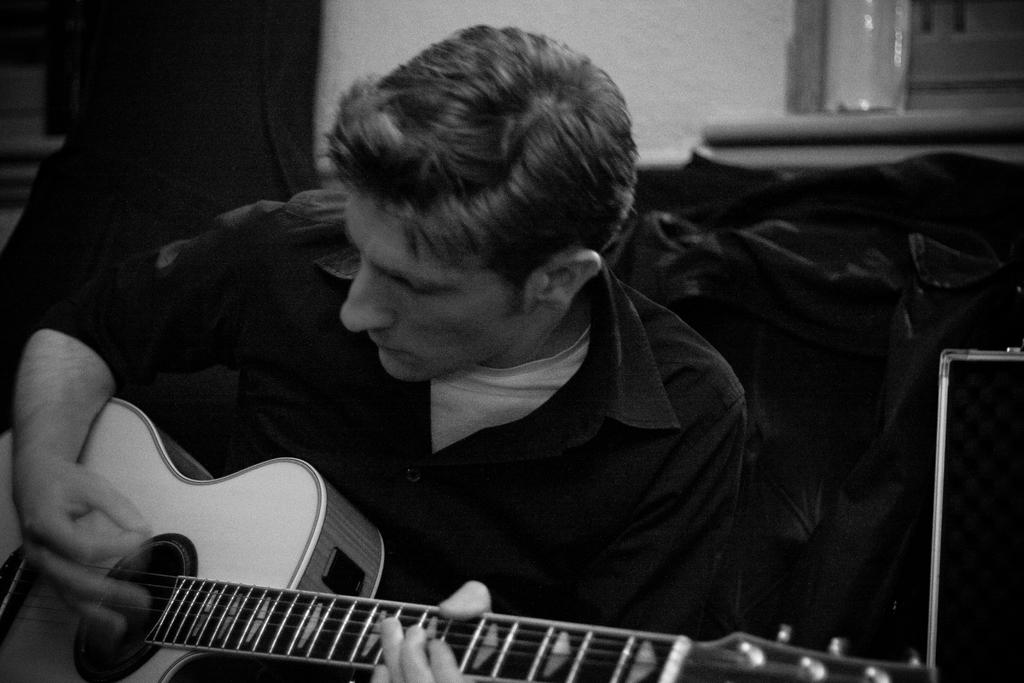What is the main subject of the image? The main subject of the image is a guy. What is the guy wearing in the image? The guy is wearing a black shirt in the image. What is the guy doing in the image? The guy is playing a guitar in the image. What can be seen in the background of the image? There is a guitar bag and a window in the background of the image. What type of fiction is the guy reading in the image? There is no book or any form of fiction present in the image. What is the friend doing in the image? There is no friend present in the image; it only features the guy playing a guitar. 